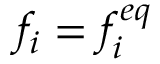Convert formula to latex. <formula><loc_0><loc_0><loc_500><loc_500>f _ { i } = f _ { i } ^ { e q }</formula> 